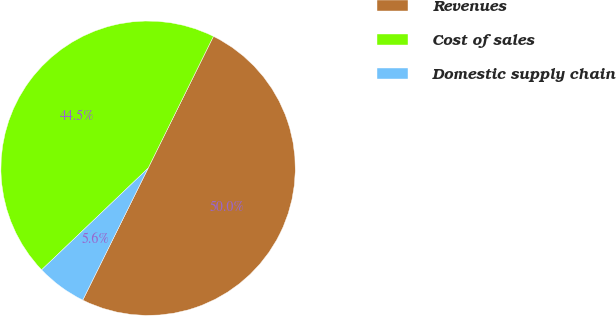<chart> <loc_0><loc_0><loc_500><loc_500><pie_chart><fcel>Revenues<fcel>Cost of sales<fcel>Domestic supply chain<nl><fcel>50.0%<fcel>44.45%<fcel>5.55%<nl></chart> 